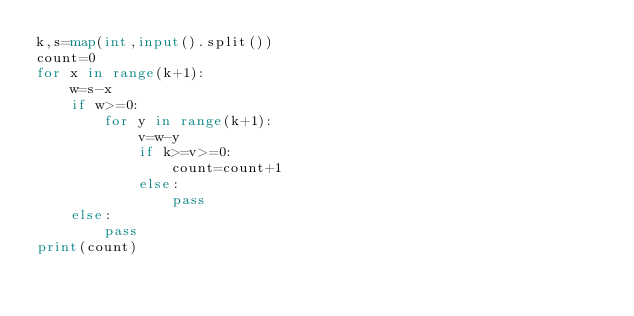<code> <loc_0><loc_0><loc_500><loc_500><_Python_>k,s=map(int,input().split())
count=0
for x in range(k+1):
    w=s-x
    if w>=0:
        for y in range(k+1):
            v=w-y
            if k>=v>=0:
                count=count+1
            else:
                pass
    else:
        pass
print(count)</code> 